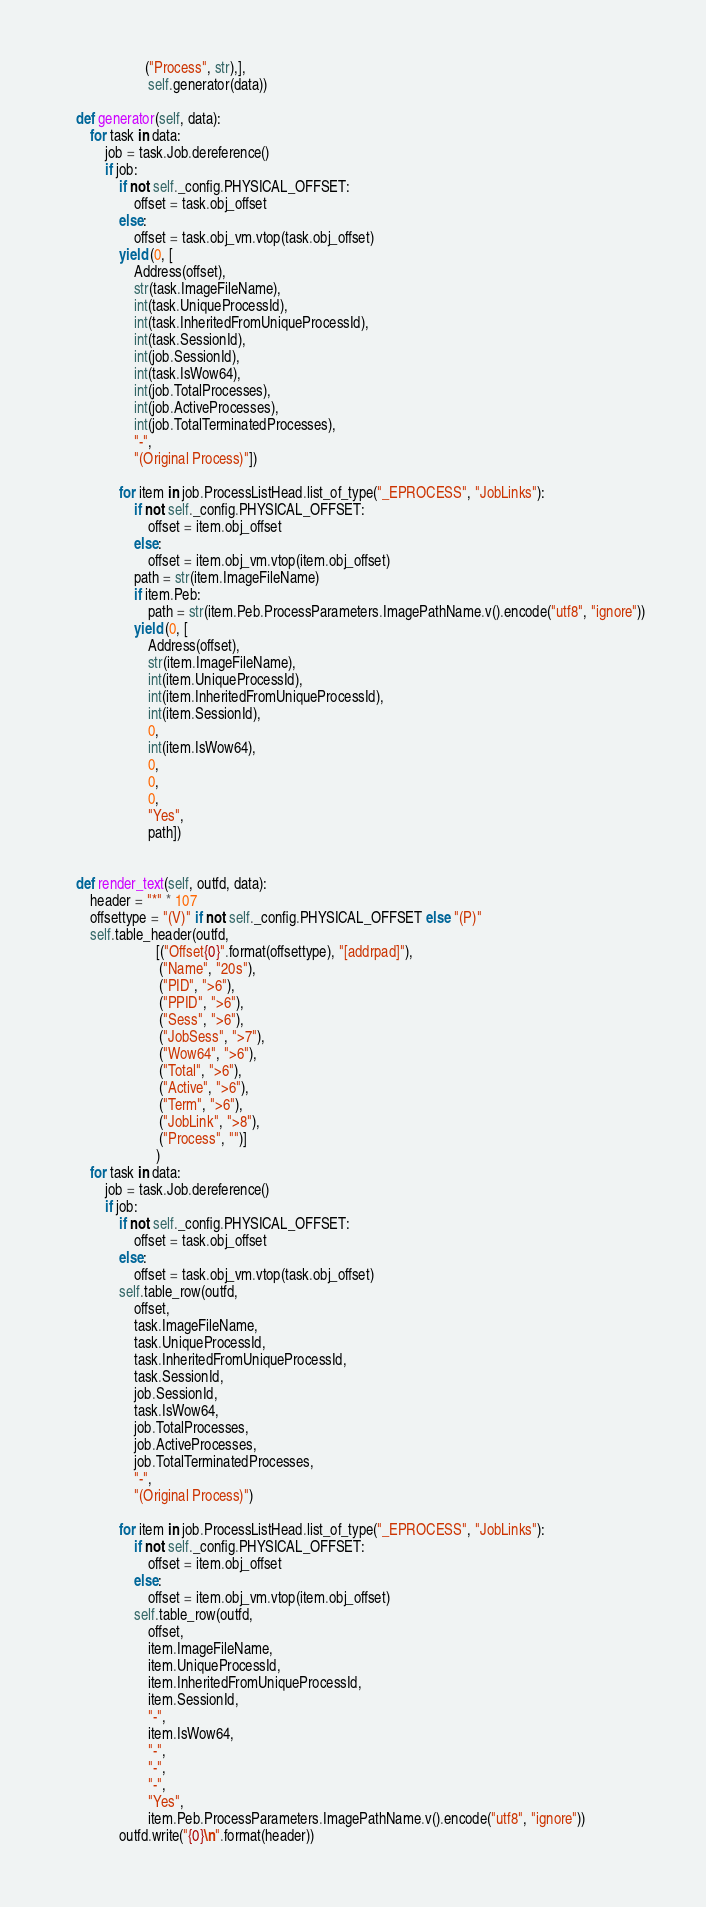<code> <loc_0><loc_0><loc_500><loc_500><_Python_>                       ("Process", str),],
                        self.generator(data))

    def generator(self, data):
        for task in data:
            job = task.Job.dereference()
            if job:
                if not self._config.PHYSICAL_OFFSET:
                    offset = task.obj_offset
                else:
                    offset = task.obj_vm.vtop(task.obj_offset)
                yield (0, [
                    Address(offset),
                    str(task.ImageFileName),
                    int(task.UniqueProcessId),
                    int(task.InheritedFromUniqueProcessId),
                    int(task.SessionId),
                    int(job.SessionId),
                    int(task.IsWow64),
                    int(job.TotalProcesses),
                    int(job.ActiveProcesses),
                    int(job.TotalTerminatedProcesses),
                    "-",
                    "(Original Process)"])

                for item in job.ProcessListHead.list_of_type("_EPROCESS", "JobLinks"):
                    if not self._config.PHYSICAL_OFFSET: 
                        offset = item.obj_offset    
                    else:       
                        offset = item.obj_vm.vtop(item.obj_offset)
                    path = str(item.ImageFileName)
                    if item.Peb:
                        path = str(item.Peb.ProcessParameters.ImagePathName.v().encode("utf8", "ignore"))
                    yield (0, [
                        Address(offset),
                        str(item.ImageFileName),
                        int(item.UniqueProcessId),
                        int(item.InheritedFromUniqueProcessId),
                        int(item.SessionId),
                        0,
                        int(item.IsWow64),
                        0,
                        0,
                        0,
                        "Yes",
                        path])


    def render_text(self, outfd, data):
        header = "*" * 107
        offsettype = "(V)" if not self._config.PHYSICAL_OFFSET else "(P)"
        self.table_header(outfd,
                          [("Offset{0}".format(offsettype), "[addrpad]"),
                           ("Name", "20s"),
                           ("PID", ">6"),
                           ("PPID", ">6"),
                           ("Sess", ">6"),
                           ("JobSess", ">7"),
                           ("Wow64", ">6"),
                           ("Total", ">6"),
                           ("Active", ">6"),
                           ("Term", ">6"),
                           ("JobLink", ">8"),
                           ("Process", "")]
                          ) 
        for task in data:
            job = task.Job.dereference()
            if job:
                if not self._config.PHYSICAL_OFFSET:
                    offset = task.obj_offset
                else:
                    offset = task.obj_vm.vtop(task.obj_offset)
                self.table_row(outfd,
                    offset,
                    task.ImageFileName,
                    task.UniqueProcessId,
                    task.InheritedFromUniqueProcessId,
                    task.SessionId,
                    job.SessionId,
                    task.IsWow64,
                    job.TotalProcesses,
                    job.ActiveProcesses,
                    job.TotalTerminatedProcesses,
                    "-",
                    "(Original Process)")

                for item in job.ProcessListHead.list_of_type("_EPROCESS", "JobLinks"):
                    if not self._config.PHYSICAL_OFFSET: 
                        offset = item.obj_offset                
                    else:                    
                        offset = item.obj_vm.vtop(item.obj_offset)
                    self.table_row(outfd,
                        offset,
                        item.ImageFileName,
                        item.UniqueProcessId,
                        item.InheritedFromUniqueProcessId,
                        item.SessionId,
                        "-",
                        item.IsWow64,
                        "-",
                        "-",
                        "-",
                        "Yes",
                        item.Peb.ProcessParameters.ImagePathName.v().encode("utf8", "ignore"))
                outfd.write("{0}\n".format(header))
</code> 